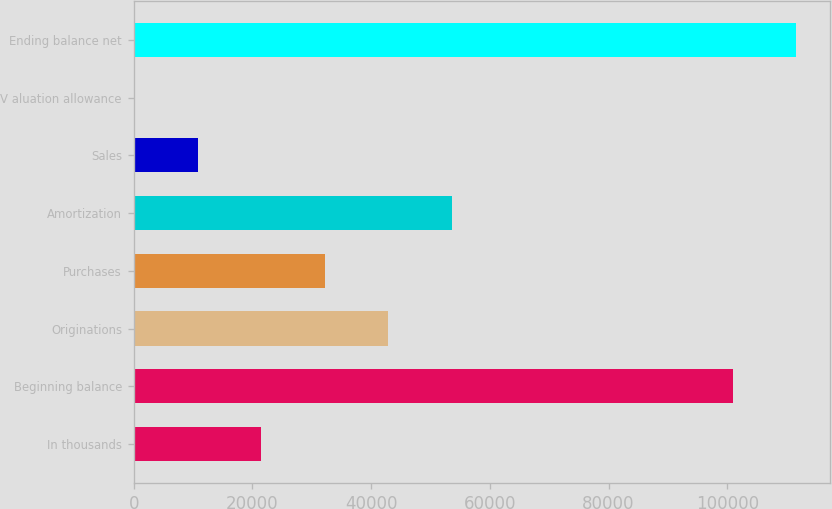<chart> <loc_0><loc_0><loc_500><loc_500><bar_chart><fcel>In thousands<fcel>Beginning balance<fcel>Originations<fcel>Purchases<fcel>Amortization<fcel>Sales<fcel>V aluation allowance<fcel>Ending balance net<nl><fcel>21464.6<fcel>100927<fcel>42879.2<fcel>32171.9<fcel>53586.5<fcel>10757.3<fcel>50<fcel>111634<nl></chart> 